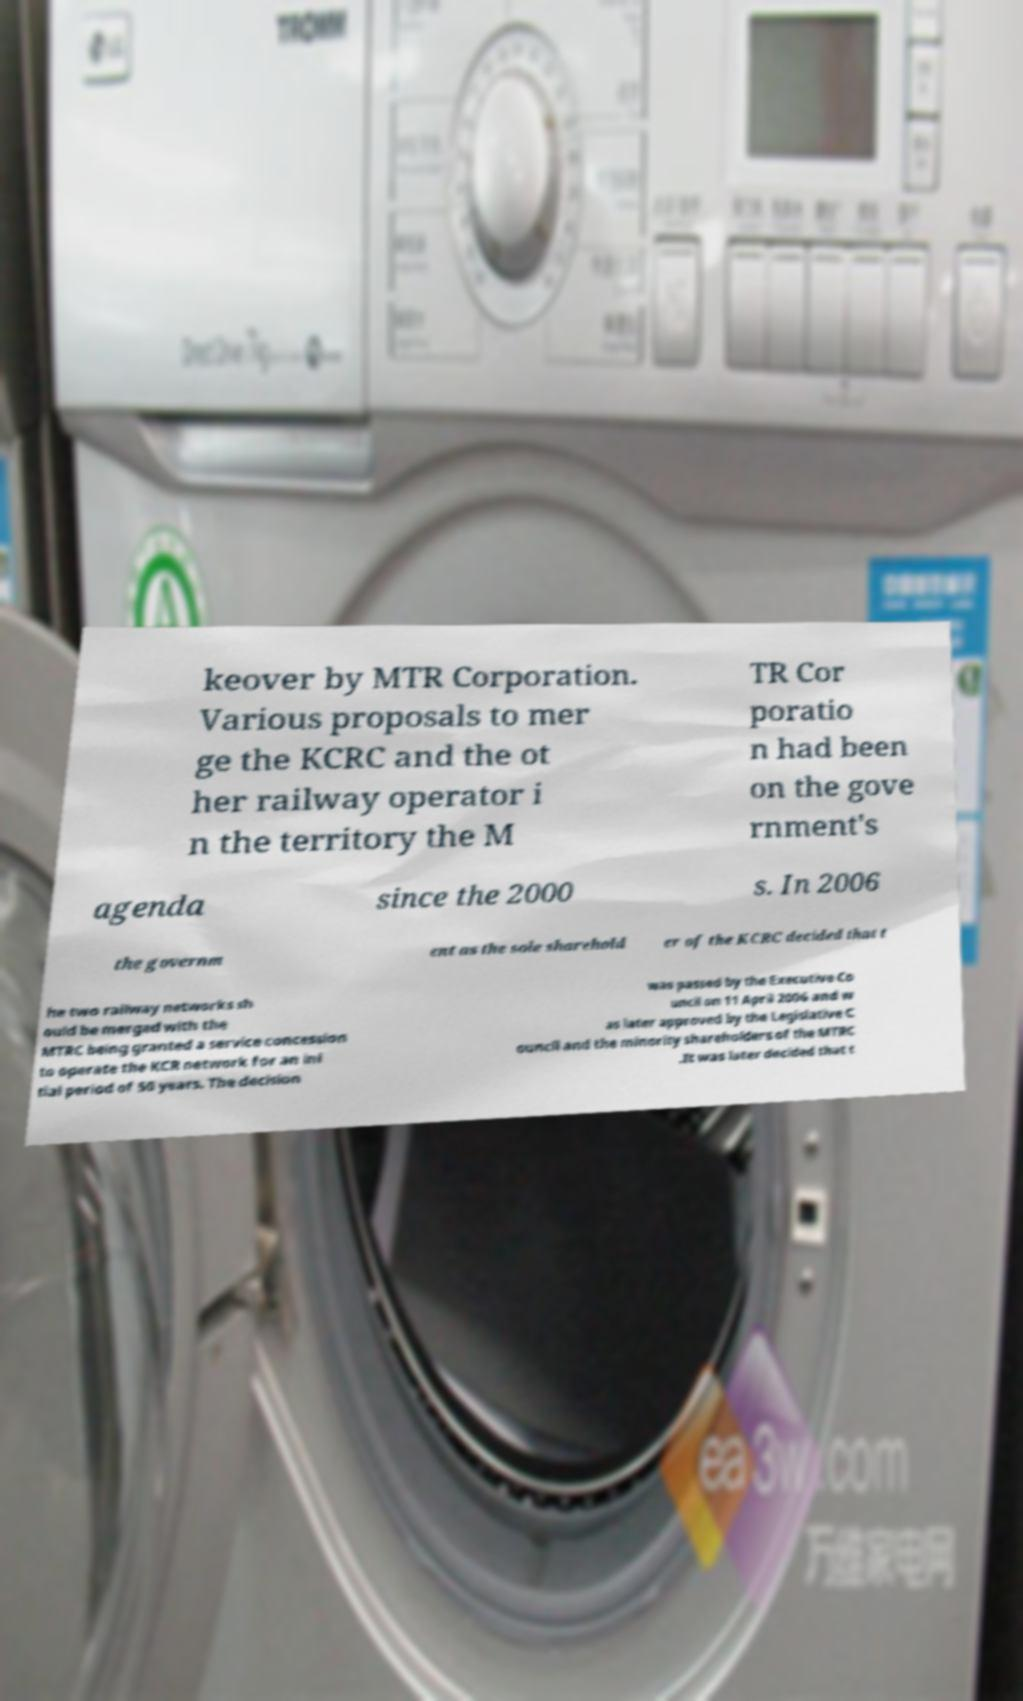What messages or text are displayed in this image? I need them in a readable, typed format. keover by MTR Corporation. Various proposals to mer ge the KCRC and the ot her railway operator i n the territory the M TR Cor poratio n had been on the gove rnment's agenda since the 2000 s. In 2006 the governm ent as the sole sharehold er of the KCRC decided that t he two railway networks sh ould be merged with the MTRC being granted a service concession to operate the KCR network for an ini tial period of 50 years. The decision was passed by the Executive Co uncil on 11 April 2006 and w as later approved by the Legislative C ouncil and the minority shareholders of the MTRC .It was later decided that t 